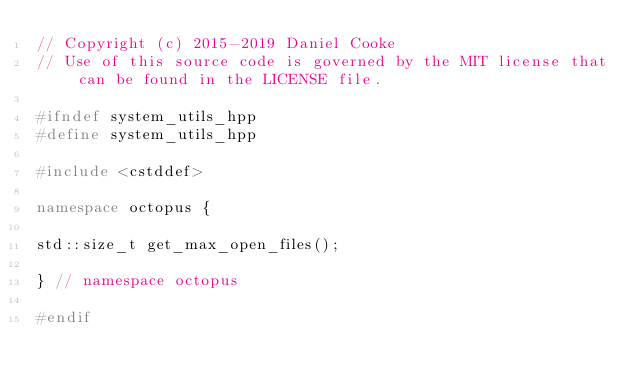<code> <loc_0><loc_0><loc_500><loc_500><_C++_>// Copyright (c) 2015-2019 Daniel Cooke
// Use of this source code is governed by the MIT license that can be found in the LICENSE file.

#ifndef system_utils_hpp
#define system_utils_hpp

#include <cstddef>

namespace octopus {

std::size_t get_max_open_files();

} // namespace octopus

#endif
</code> 